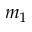Convert formula to latex. <formula><loc_0><loc_0><loc_500><loc_500>m _ { 1 }</formula> 